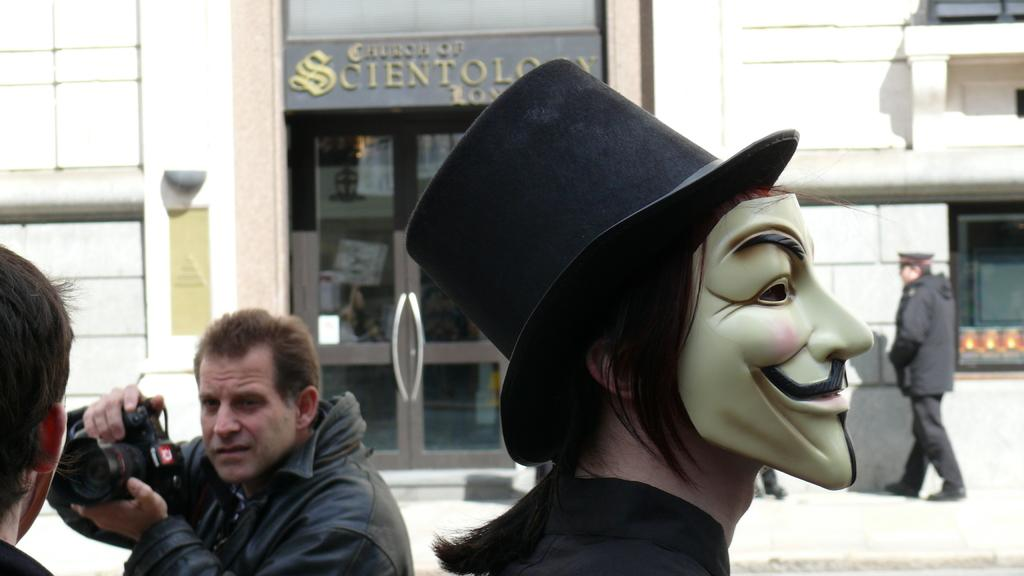Who is present in the image? There is a man in the image. What is the man holding in his hands? The man is holding a camera in his hands. What can be seen in the image besides the man and the camera? There is a mask, a building, a board, and a door visible in the image. What type of wound can be seen on the man's leg in the image? There is no wound visible on the man's leg in the image. What date is marked on the calendar in the image? There is no calendar present in the image. 